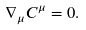Convert formula to latex. <formula><loc_0><loc_0><loc_500><loc_500>\nabla _ { \mu } C ^ { \mu } = 0 .</formula> 